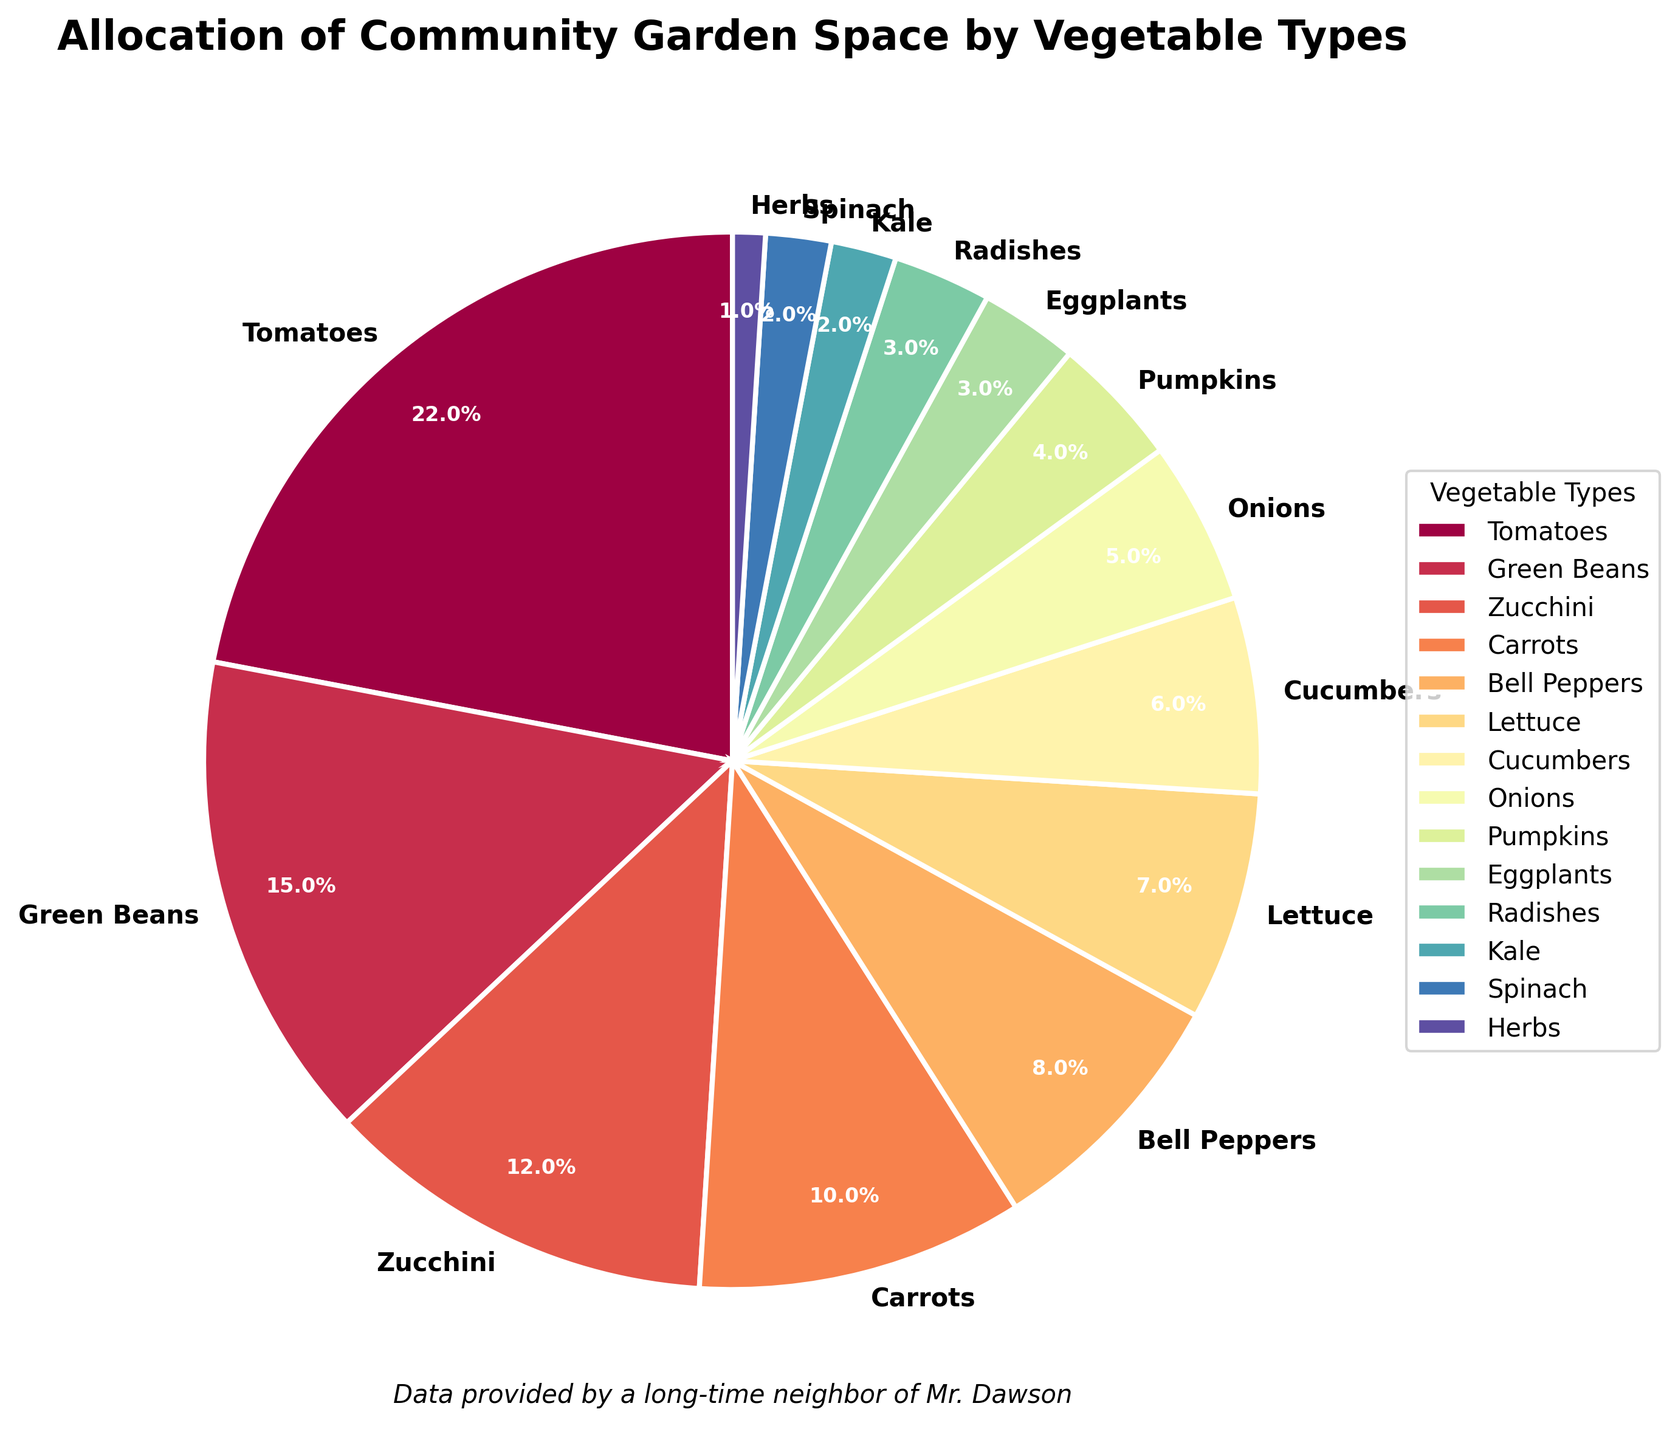Which vegetable type takes up the most space in the community garden? The largest portion of the pie chart is for Tomatoes.
Answer: Tomatoes What is the combined percentage of the garden space taken by Carrots and Bell Peppers? Carrots take up 10% and Bell Peppers take up 8%. Adding these together gives 10% + 8% = 18%.
Answer: 18% Which vegetable types occupy the least amount of space in the community garden? The smallest percentages (1%) are for Herbs.
Answer: Herbs How many vegetable types occupy more than 10% of the garden space each? Tomatoes (22%), Green Beans (15%), and Zucchini (12%) each occupy more than 10% of the space. That's three types.
Answer: 3 What is the difference in the garden space allocation between Spinach and Cucumbers? Cucumbers take up 6% while Spinach takes up 2%. Subtracting these gives 6% - 2% = 4%.
Answer: 4% Which vegetable type has the third largest allocation of garden space? The third largest segment in the pie chart is for Zucchini, which takes up 12% of the space.
Answer: Zucchini Is the combined garden space for all types of greens (Lettuce, Kale, Spinach) more than or less than that for Tomatoes? Lettuce (7%) + Kale (2%) + Spinach (2%) = 11%. Tomatoes take up 22%. Therefore, the combined space for greens is less than that for Tomatoes.
Answer: Less than What proportion of the garden is allocated to vegetables that take up less than 5% each? Onions (5%), Pumpkins (4%), Eggplants (3%), Radishes (3%), Kale (2%), Spinach (2%), and Herbs (1%) are each taking up less than 5%. Adding these gives 5% + 4% + 3% + 3% + 2% + 2% + 1% = 20%.
Answer: 20% Which vegetable type occupying garden space between 5% and 10% appears earliest in the legend? Lettuce occupies 7% of the space and it appears before Cucumbers (6%) and Onions (5%) in the legend.
Answer: Lettuce 